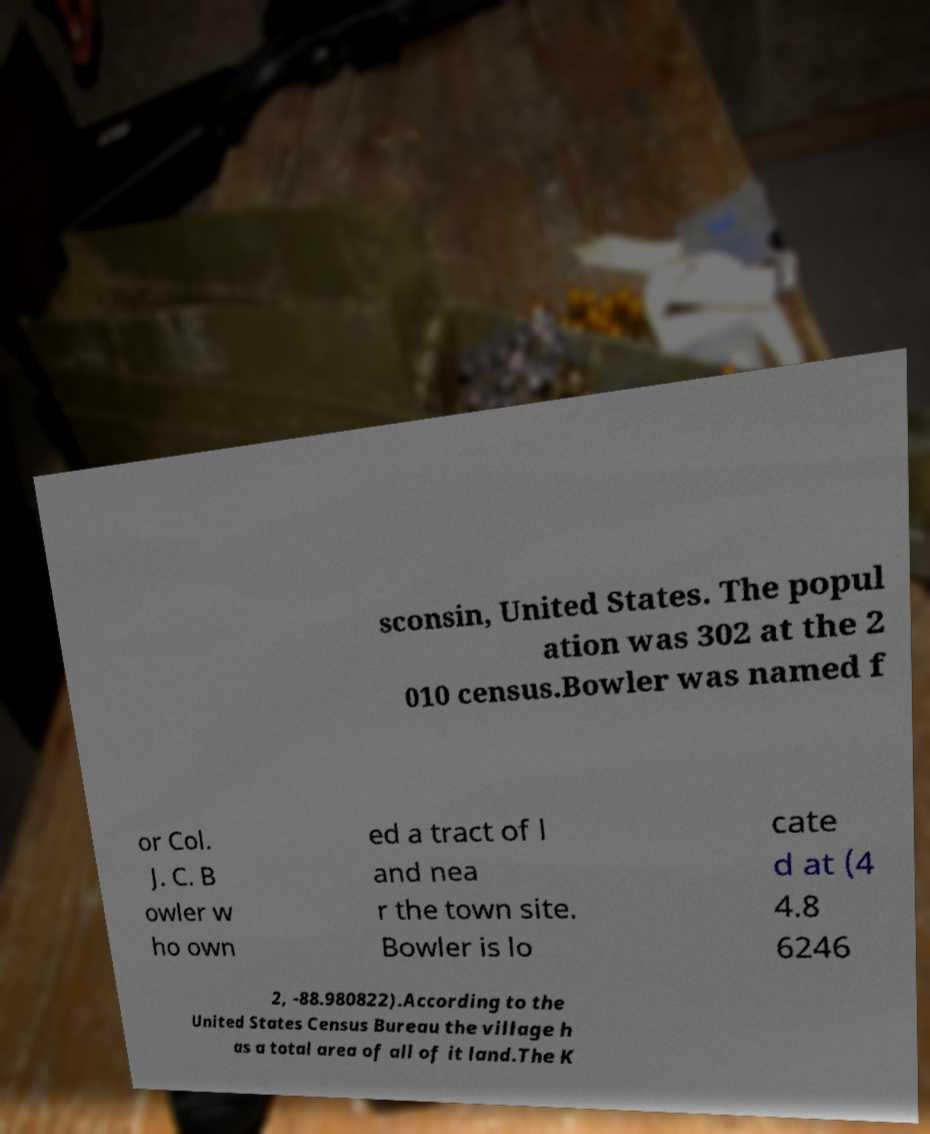For documentation purposes, I need the text within this image transcribed. Could you provide that? sconsin, United States. The popul ation was 302 at the 2 010 census.Bowler was named f or Col. J. C. B owler w ho own ed a tract of l and nea r the town site. Bowler is lo cate d at (4 4.8 6246 2, -88.980822).According to the United States Census Bureau the village h as a total area of all of it land.The K 